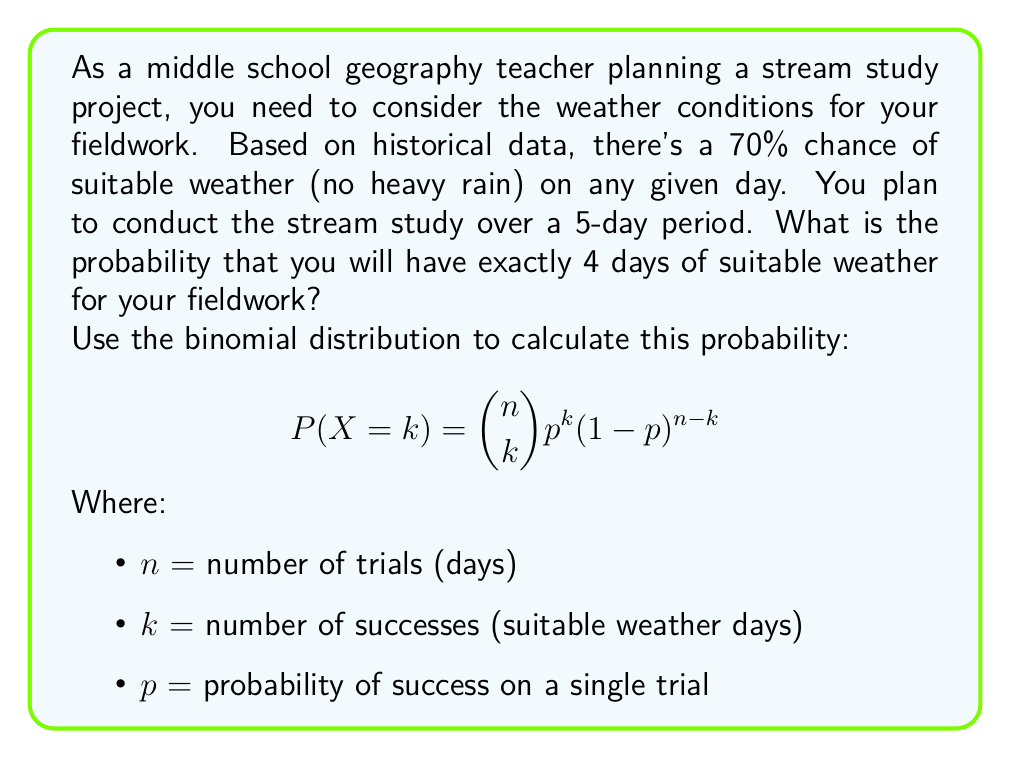Could you help me with this problem? To solve this problem, we'll use the binomial distribution formula:

$$P(X=k) = \binom{n}{k} p^k (1-p)^{n-k}$$

Given:
n = 5 (total number of days)
k = 4 (number of suitable weather days we want)
p = 0.70 (probability of suitable weather on any given day)

Step 1: Calculate the binomial coefficient $\binom{n}{k}$
$$\binom{5}{4} = \frac{5!}{4!(5-4)!} = \frac{5!}{4!(1)!} = 5$$

Step 2: Calculate $p^k$
$$0.70^4 = 0.2401$$

Step 3: Calculate $(1-p)^{n-k}$
$$(1-0.70)^{5-4} = 0.30^1 = 0.30$$

Step 4: Multiply all parts together
$$P(X=4) = 5 \times 0.2401 \times 0.30 = 0.36015$$

Therefore, the probability of having exactly 4 days of suitable weather out of 5 days is approximately 0.36015 or 36.015%.
Answer: 0.36015 or 36.015% 